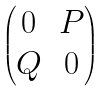Convert formula to latex. <formula><loc_0><loc_0><loc_500><loc_500>\begin{pmatrix} 0 & P \\ Q & 0 \end{pmatrix}</formula> 